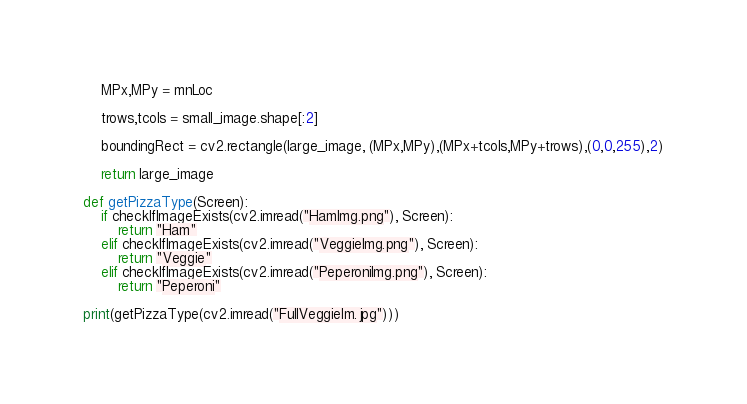<code> <loc_0><loc_0><loc_500><loc_500><_Python_>    MPx,MPy = mnLoc

    trows,tcols = small_image.shape[:2]

    boundingRect = cv2.rectangle(large_image, (MPx,MPy),(MPx+tcols,MPy+trows),(0,0,255),2)

    return large_image

def getPizzaType(Screen):
    if checkIfImageExists(cv2.imread("HamImg.png"), Screen):
        return "Ham"
    elif checkIfImageExists(cv2.imread("VeggieImg.png"), Screen):
        return "Veggie"
    elif checkIfImageExists(cv2.imread("PeperoniImg.png"), Screen):
        return "Peperoni"

print(getPizzaType(cv2.imread("FullVeggieIm.jpg")))</code> 